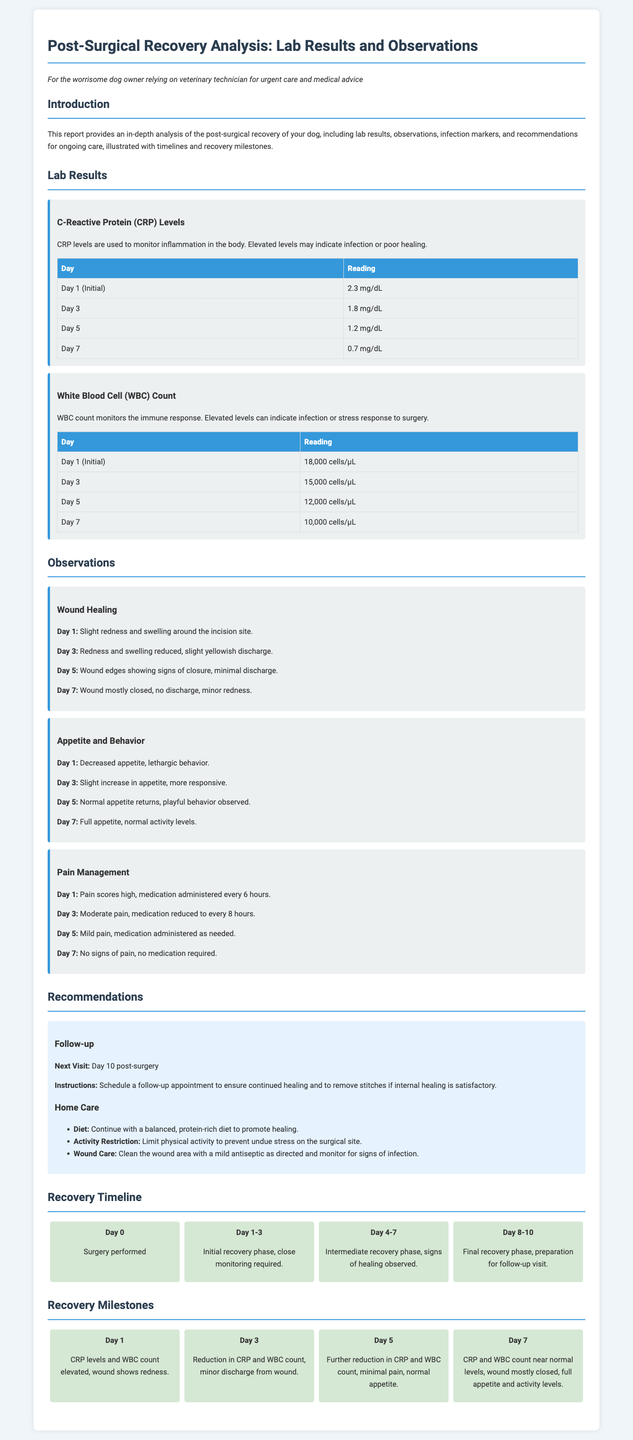What were the CRP levels on Day 1? The table shows that the CRP level on Day 1 was 2.3 mg/dL.
Answer: 2.3 mg/dL What is the WBC count on Day 7? According to the lab results, the WBC count on Day 7 was 10,000 cells/µL.
Answer: 10,000 cells/µL What signs were observed in wound healing on Day 5? The observation notes indicated that on Day 5, the wound edges were showing signs of closure, with minimal discharge.
Answer: Signs of closure, minimal discharge What was the pain score and medication status on Day 3? The pain management section states that on Day 3, the pain score was moderate and medication was reduced to every 8 hours.
Answer: Moderate pain, every 8 hours What is the recommended follow-up visit day? The recommendations section specifies that the next follow-up visit should be on Day 10 post-surgery.
Answer: Day 10 What was the dog's appetite level on Day 1? The observations recorded that the appetite was decreased on Day 1.
Answer: Decreased appetite What phase of recovery is expected between Day 0 and Day 3? The recovery timeline indicates that the initial recovery phase requires close monitoring between Day 1 and Day 3.
Answer: Initial recovery phase What were the days when CRP levels showed reduction? The lab results indicated that CRP levels showed reduction on Days 3, 5, and 7.
Answer: Days 3, 5, and 7 What is the recommendation for wound care? The recommendations specify to clean the wound area with a mild antiseptic as directed and monitor for signs of infection.
Answer: Clean with mild antiseptic, monitor for infection 